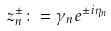<formula> <loc_0><loc_0><loc_500><loc_500>z _ { n } ^ { \pm } \colon = \gamma _ { n } e ^ { \pm i \eta _ { n } }</formula> 